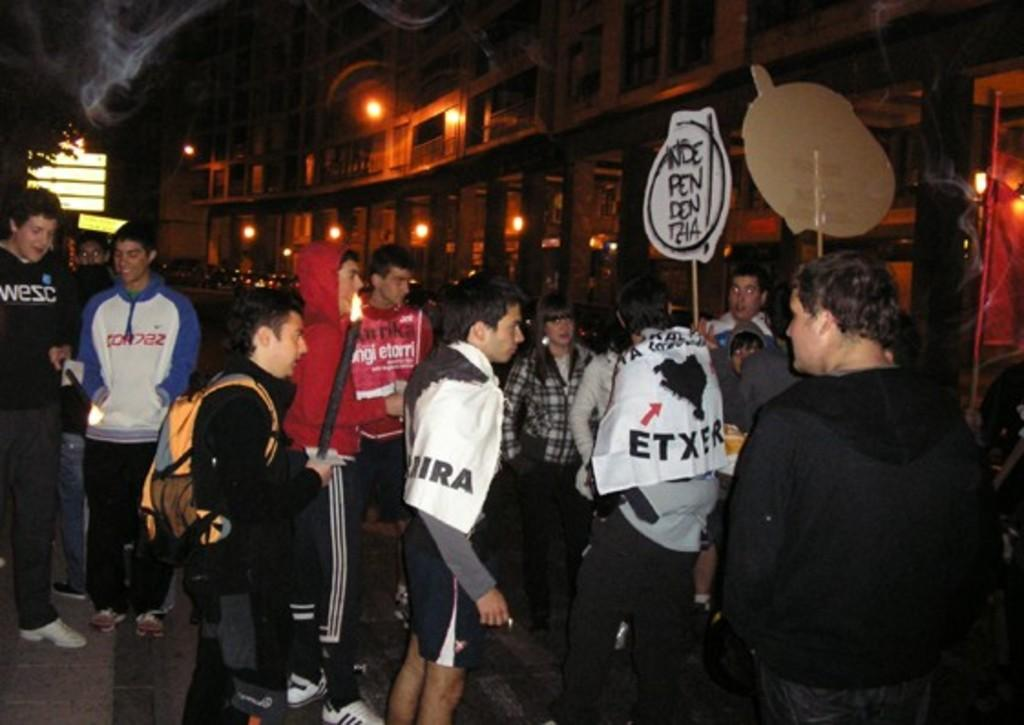How many people are present in the image? There are people in the image, but the exact number is not specified. What are two people doing in the image? Two people are holding boards, and two people are holding fire objects. What can be seen in the background of the image? There are buildings, lights, and a tree. How many dimes can be seen on the ground in the image? There is no mention of dimes in the image, so it is not possible to determine their presence or quantity. 